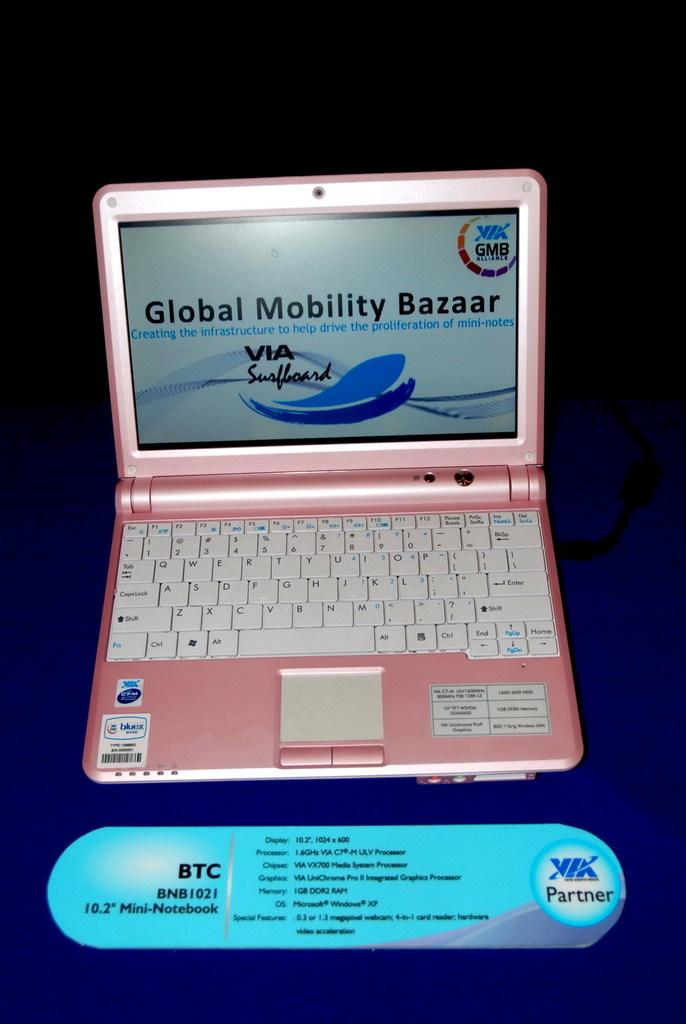<image>
Relay a brief, clear account of the picture shown. A pink laptop that has a page loaded on the screen that says Global Mobility Bazaar 